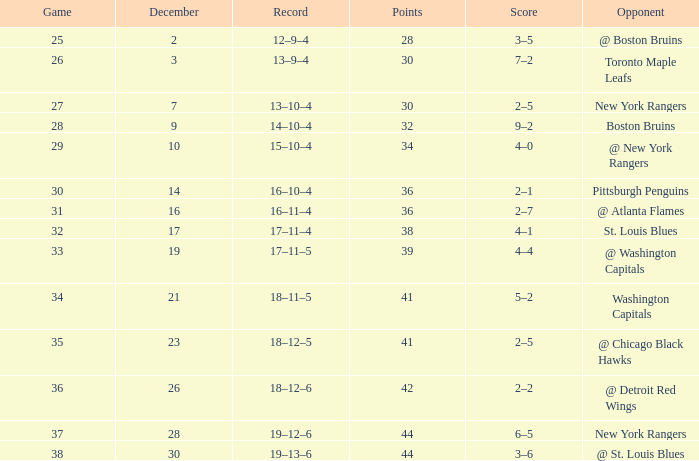Which Game has a Score of 4–1? 32.0. 